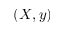Convert formula to latex. <formula><loc_0><loc_0><loc_500><loc_500>( X , y )</formula> 